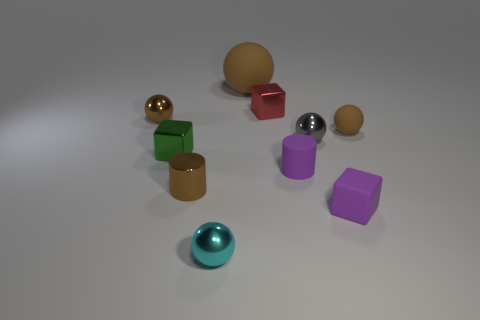Subtract all rubber spheres. How many spheres are left? 3 Subtract all purple cylinders. How many cylinders are left? 1 Subtract 2 spheres. How many spheres are left? 3 Subtract all red cylinders. How many brown balls are left? 3 Subtract all cubes. How many objects are left? 7 Subtract all purple balls. Subtract all yellow cylinders. How many balls are left? 5 Subtract all blue spheres. Subtract all small purple matte objects. How many objects are left? 8 Add 3 purple objects. How many purple objects are left? 5 Add 7 small purple rubber cylinders. How many small purple rubber cylinders exist? 8 Subtract 2 brown balls. How many objects are left? 8 